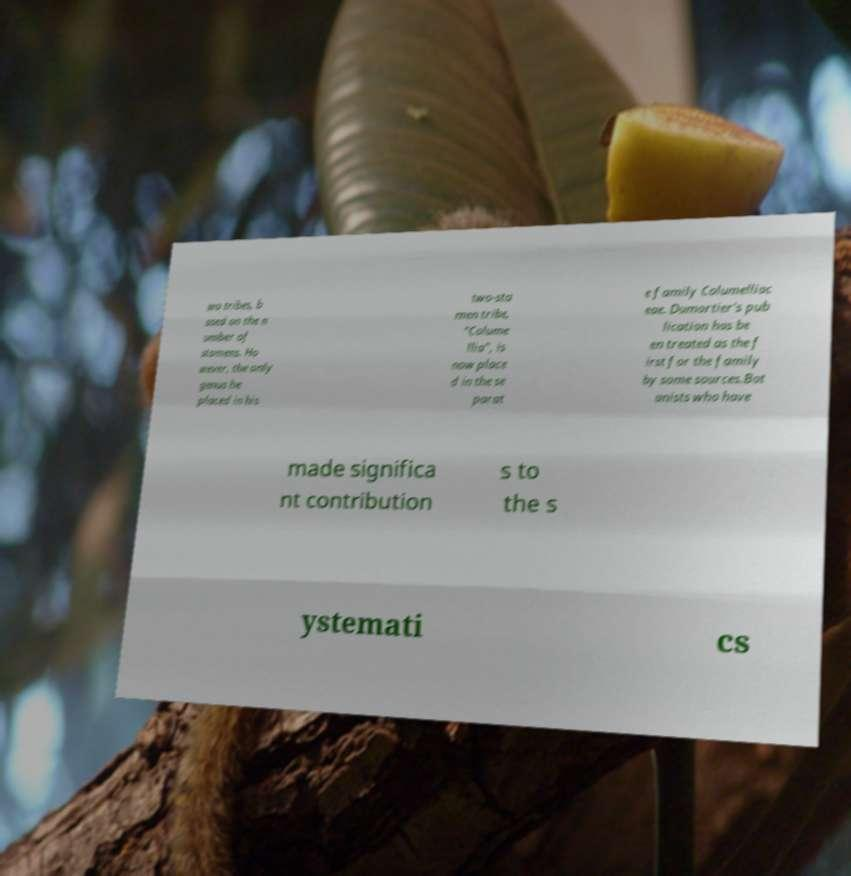Please read and relay the text visible in this image. What does it say? wo tribes, b ased on the n umber of stamens. Ho wever, the only genus he placed in his two-sta men tribe, "Colume llia", is now place d in the se parat e family Columelliac eae. Dumortier's pub lication has be en treated as the f irst for the family by some sources.Bot anists who have made significa nt contribution s to the s ystemati cs 